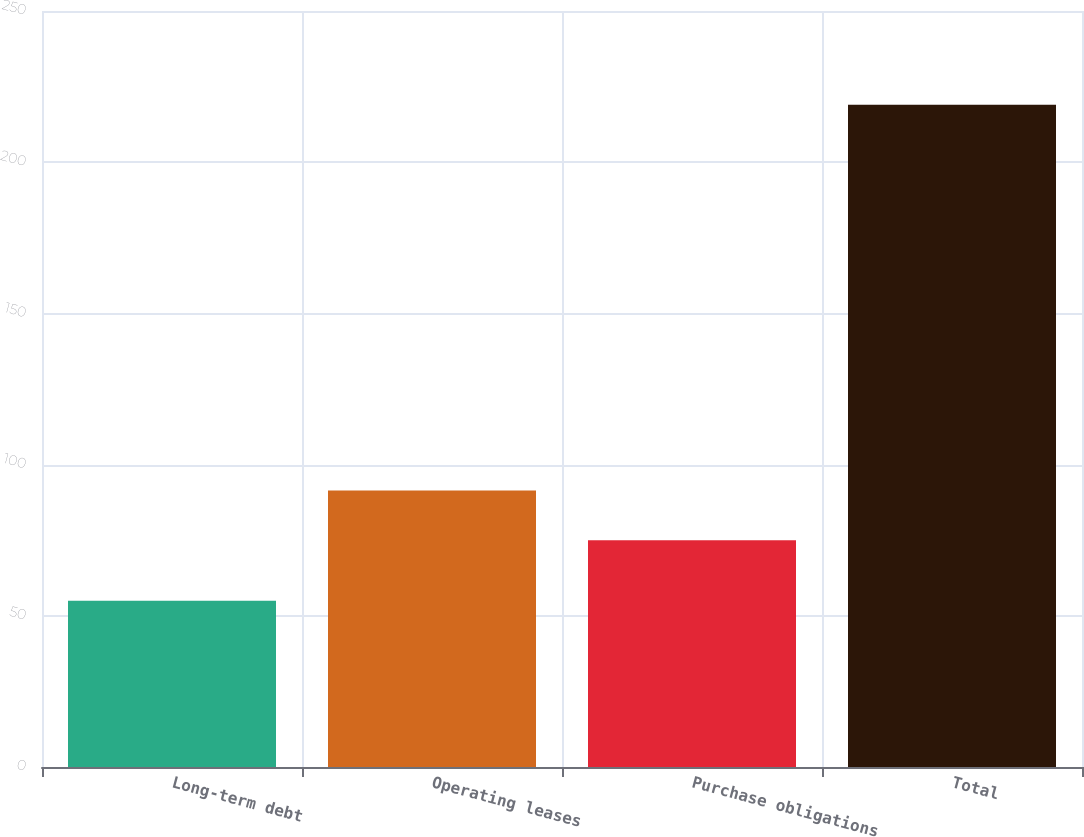<chart> <loc_0><loc_0><loc_500><loc_500><bar_chart><fcel>Long-term debt<fcel>Operating leases<fcel>Purchase obligations<fcel>Total<nl><fcel>55<fcel>91.4<fcel>75<fcel>219<nl></chart> 